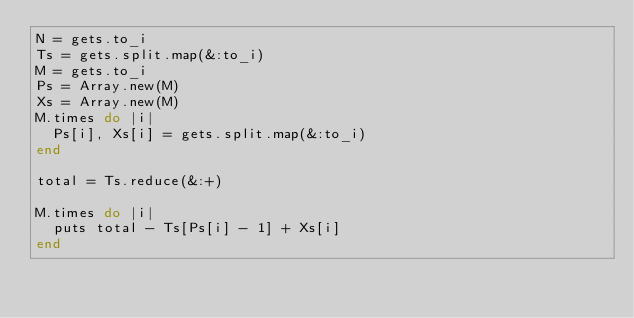<code> <loc_0><loc_0><loc_500><loc_500><_Ruby_>N = gets.to_i
Ts = gets.split.map(&:to_i)
M = gets.to_i
Ps = Array.new(M)
Xs = Array.new(M)
M.times do |i|
  Ps[i], Xs[i] = gets.split.map(&:to_i)
end

total = Ts.reduce(&:+)

M.times do |i|
  puts total - Ts[Ps[i] - 1] + Xs[i]
end
</code> 